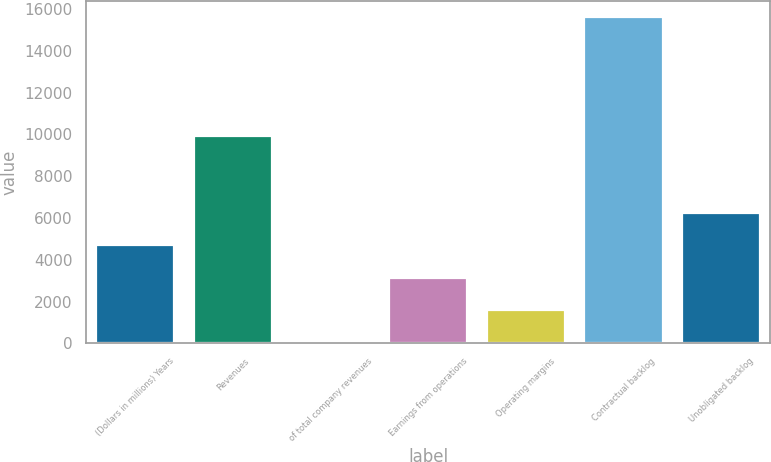<chart> <loc_0><loc_0><loc_500><loc_500><bar_chart><fcel>(Dollars in millions) Years<fcel>Revenues<fcel>of total company revenues<fcel>Earnings from operations<fcel>Operating margins<fcel>Contractual backlog<fcel>Unobligated backlog<nl><fcel>4690.7<fcel>9937<fcel>11<fcel>3130.8<fcel>1570.9<fcel>15610<fcel>6250.6<nl></chart> 